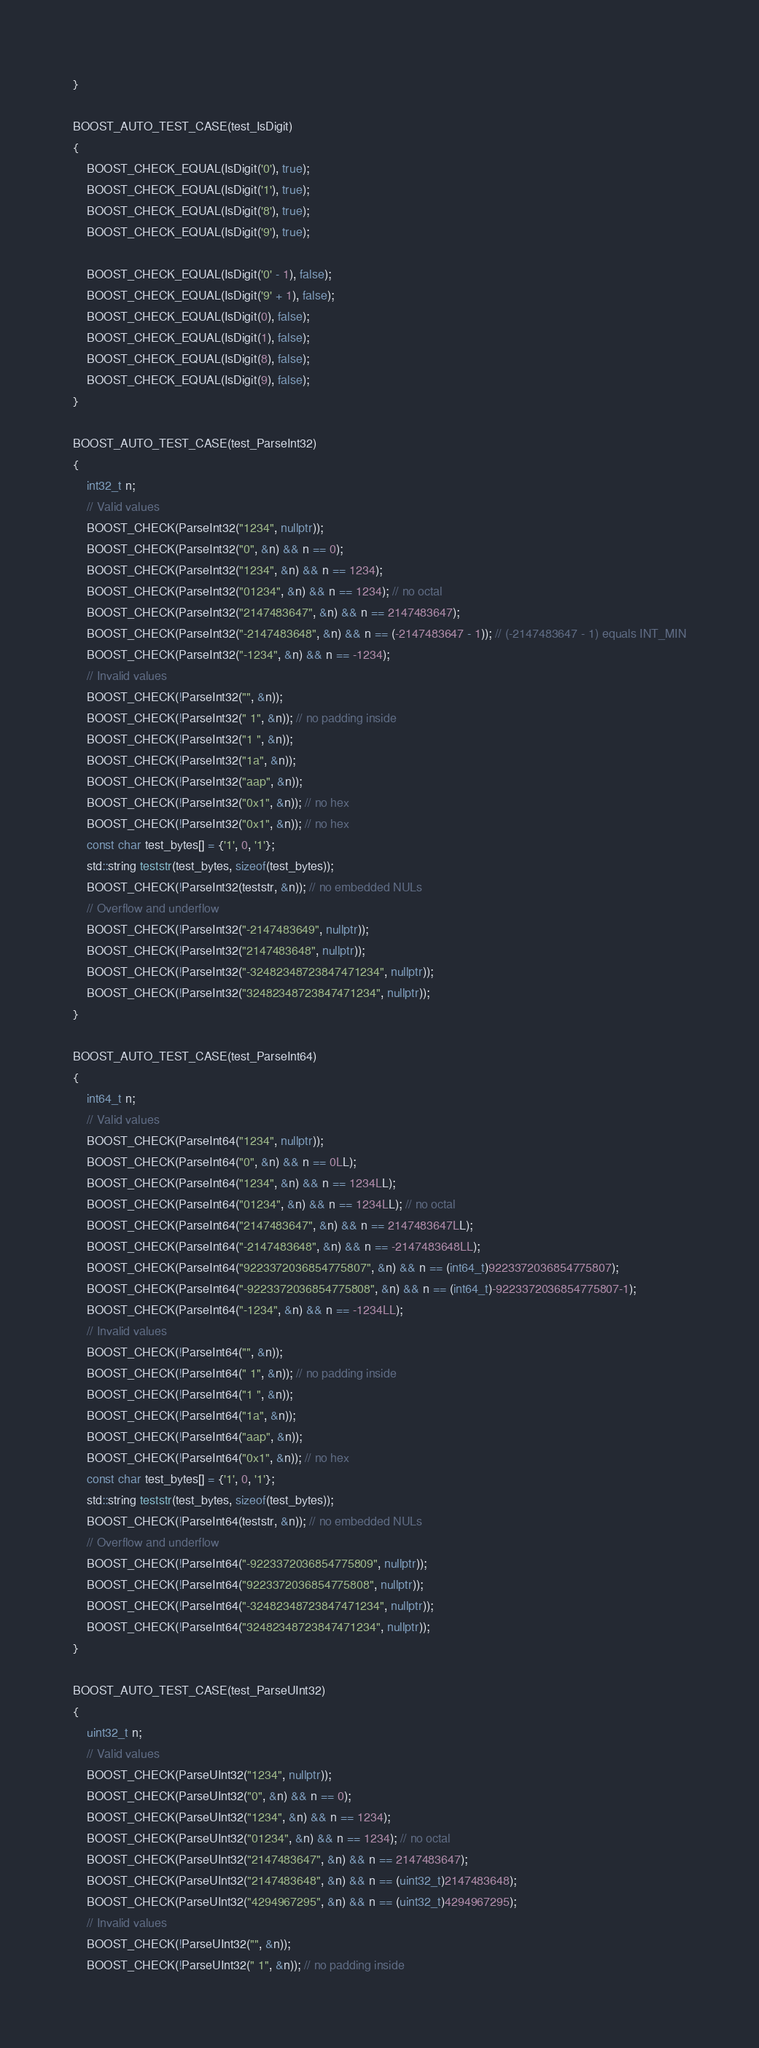<code> <loc_0><loc_0><loc_500><loc_500><_C++_>}

BOOST_AUTO_TEST_CASE(test_IsDigit)
{
    BOOST_CHECK_EQUAL(IsDigit('0'), true);
    BOOST_CHECK_EQUAL(IsDigit('1'), true);
    BOOST_CHECK_EQUAL(IsDigit('8'), true);
    BOOST_CHECK_EQUAL(IsDigit('9'), true);

    BOOST_CHECK_EQUAL(IsDigit('0' - 1), false);
    BOOST_CHECK_EQUAL(IsDigit('9' + 1), false);
    BOOST_CHECK_EQUAL(IsDigit(0), false);
    BOOST_CHECK_EQUAL(IsDigit(1), false);
    BOOST_CHECK_EQUAL(IsDigit(8), false);
    BOOST_CHECK_EQUAL(IsDigit(9), false);
}

BOOST_AUTO_TEST_CASE(test_ParseInt32)
{
    int32_t n;
    // Valid values
    BOOST_CHECK(ParseInt32("1234", nullptr));
    BOOST_CHECK(ParseInt32("0", &n) && n == 0);
    BOOST_CHECK(ParseInt32("1234", &n) && n == 1234);
    BOOST_CHECK(ParseInt32("01234", &n) && n == 1234); // no octal
    BOOST_CHECK(ParseInt32("2147483647", &n) && n == 2147483647);
    BOOST_CHECK(ParseInt32("-2147483648", &n) && n == (-2147483647 - 1)); // (-2147483647 - 1) equals INT_MIN
    BOOST_CHECK(ParseInt32("-1234", &n) && n == -1234);
    // Invalid values
    BOOST_CHECK(!ParseInt32("", &n));
    BOOST_CHECK(!ParseInt32(" 1", &n)); // no padding inside
    BOOST_CHECK(!ParseInt32("1 ", &n));
    BOOST_CHECK(!ParseInt32("1a", &n));
    BOOST_CHECK(!ParseInt32("aap", &n));
    BOOST_CHECK(!ParseInt32("0x1", &n)); // no hex
    BOOST_CHECK(!ParseInt32("0x1", &n)); // no hex
    const char test_bytes[] = {'1', 0, '1'};
    std::string teststr(test_bytes, sizeof(test_bytes));
    BOOST_CHECK(!ParseInt32(teststr, &n)); // no embedded NULs
    // Overflow and underflow
    BOOST_CHECK(!ParseInt32("-2147483649", nullptr));
    BOOST_CHECK(!ParseInt32("2147483648", nullptr));
    BOOST_CHECK(!ParseInt32("-32482348723847471234", nullptr));
    BOOST_CHECK(!ParseInt32("32482348723847471234", nullptr));
}

BOOST_AUTO_TEST_CASE(test_ParseInt64)
{
    int64_t n;
    // Valid values
    BOOST_CHECK(ParseInt64("1234", nullptr));
    BOOST_CHECK(ParseInt64("0", &n) && n == 0LL);
    BOOST_CHECK(ParseInt64("1234", &n) && n == 1234LL);
    BOOST_CHECK(ParseInt64("01234", &n) && n == 1234LL); // no octal
    BOOST_CHECK(ParseInt64("2147483647", &n) && n == 2147483647LL);
    BOOST_CHECK(ParseInt64("-2147483648", &n) && n == -2147483648LL);
    BOOST_CHECK(ParseInt64("9223372036854775807", &n) && n == (int64_t)9223372036854775807);
    BOOST_CHECK(ParseInt64("-9223372036854775808", &n) && n == (int64_t)-9223372036854775807-1);
    BOOST_CHECK(ParseInt64("-1234", &n) && n == -1234LL);
    // Invalid values
    BOOST_CHECK(!ParseInt64("", &n));
    BOOST_CHECK(!ParseInt64(" 1", &n)); // no padding inside
    BOOST_CHECK(!ParseInt64("1 ", &n));
    BOOST_CHECK(!ParseInt64("1a", &n));
    BOOST_CHECK(!ParseInt64("aap", &n));
    BOOST_CHECK(!ParseInt64("0x1", &n)); // no hex
    const char test_bytes[] = {'1', 0, '1'};
    std::string teststr(test_bytes, sizeof(test_bytes));
    BOOST_CHECK(!ParseInt64(teststr, &n)); // no embedded NULs
    // Overflow and underflow
    BOOST_CHECK(!ParseInt64("-9223372036854775809", nullptr));
    BOOST_CHECK(!ParseInt64("9223372036854775808", nullptr));
    BOOST_CHECK(!ParseInt64("-32482348723847471234", nullptr));
    BOOST_CHECK(!ParseInt64("32482348723847471234", nullptr));
}

BOOST_AUTO_TEST_CASE(test_ParseUInt32)
{
    uint32_t n;
    // Valid values
    BOOST_CHECK(ParseUInt32("1234", nullptr));
    BOOST_CHECK(ParseUInt32("0", &n) && n == 0);
    BOOST_CHECK(ParseUInt32("1234", &n) && n == 1234);
    BOOST_CHECK(ParseUInt32("01234", &n) && n == 1234); // no octal
    BOOST_CHECK(ParseUInt32("2147483647", &n) && n == 2147483647);
    BOOST_CHECK(ParseUInt32("2147483648", &n) && n == (uint32_t)2147483648);
    BOOST_CHECK(ParseUInt32("4294967295", &n) && n == (uint32_t)4294967295);
    // Invalid values
    BOOST_CHECK(!ParseUInt32("", &n));
    BOOST_CHECK(!ParseUInt32(" 1", &n)); // no padding inside</code> 